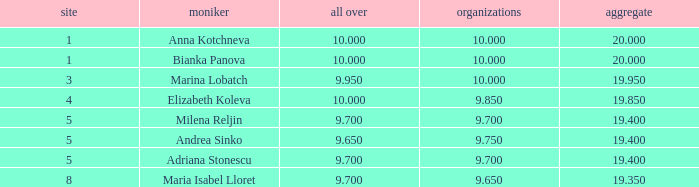Help me parse the entirety of this table. {'header': ['site', 'moniker', 'all over', 'organizations', 'aggregate'], 'rows': [['1', 'Anna Kotchneva', '10.000', '10.000', '20.000'], ['1', 'Bianka Panova', '10.000', '10.000', '20.000'], ['3', 'Marina Lobatch', '9.950', '10.000', '19.950'], ['4', 'Elizabeth Koleva', '10.000', '9.850', '19.850'], ['5', 'Milena Reljin', '9.700', '9.700', '19.400'], ['5', 'Andrea Sinko', '9.650', '9.750', '19.400'], ['5', 'Adriana Stonescu', '9.700', '9.700', '19.400'], ['8', 'Maria Isabel Lloret', '9.700', '9.650', '19.350']]} How many places have bianka panova as the name, with clubs less than 10? 0.0. 